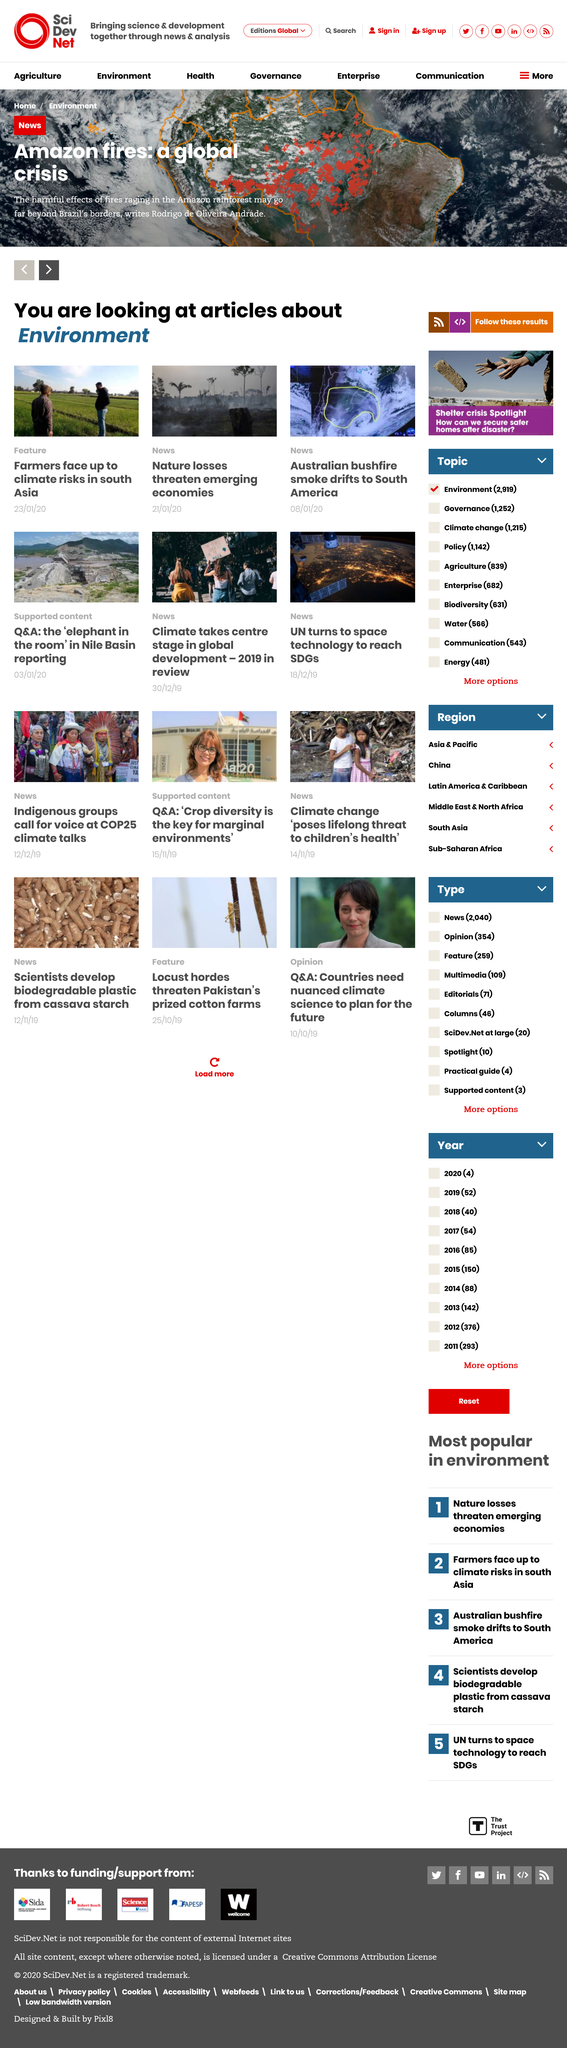Draw attention to some important aspects in this diagram. The smoke from the devastating Australian bushfires is drifting towards South America, causing serious health and environmental concerns for the region. The writer of the article about Amazon fires is Rodrigo de Oliveira Andrade. The articles pictured are all about the environment. 